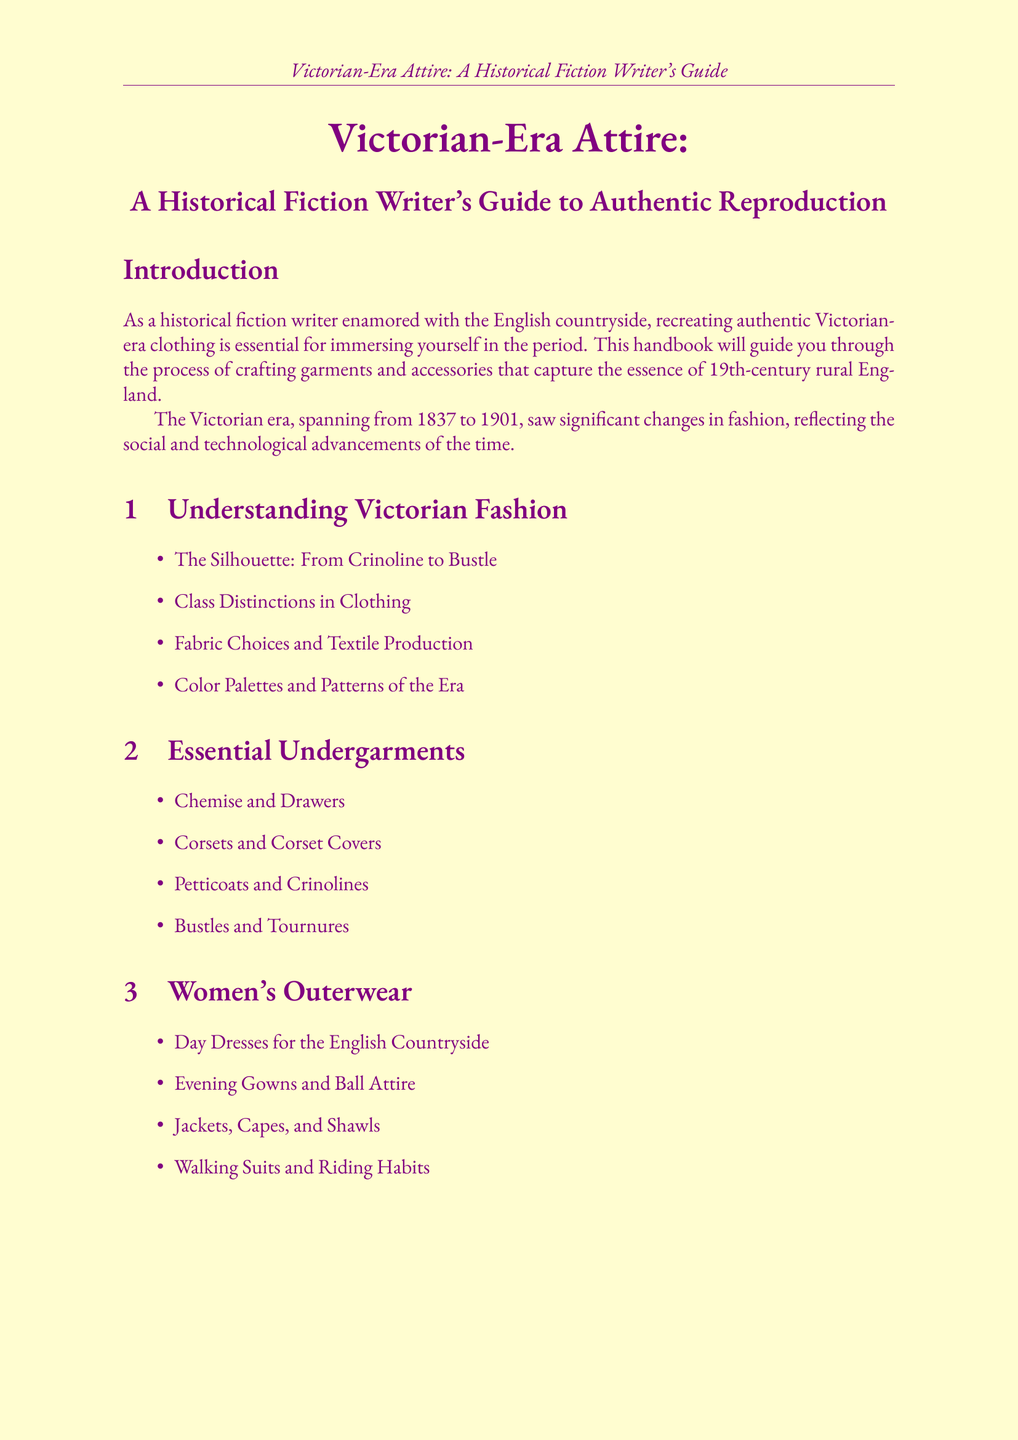What is the title of the handbook? The title of the handbook is stated at the beginning of the document.
Answer: Victorian-Era Attire: A Historical Fiction Writer's Guide to Authentic Reproduction What years define the Victorian era? The years of the Victorian era are provided in the historical context section of the introduction.
Answer: 1837 to 1901 Which pattern is featured for the 1870s? The patterns and construction section lists specific patterns, including that for the 1870s.
Answer: 1870s Bustle Gown Pattern What type of fabrics does Wm. Booth, Draper specialize in? The fabric suppliers section mentions the specialization of each supplier.
Answer: Historical fabrics Name one museum listed in the document. The museums and collections section provides a list of various museums related to fashion history.
Answer: Victoria and Albert Museum What is the focus of the "Embellishments and Trimmings" chapter? This chapter details different types of enhancements that can be added to garments, as described in its title.
Answer: Lace, Ribbons, Beadwork, Embroidery How many appendices are included in the document? The conclusion of the document lists all sections, including the appendices, which totals them.
Answer: Four Which company offers authentic Victorian era patterns? The pattern companies section provides a list including specific companies that meet this criterion.
Answer: Truly Victorian What is the purpose of the "Glossary of Victorian Fashion Terms"? The appendices outline the function of each appendix, clarifying its content.
Answer: A comprehensive list of period-specific terminology 